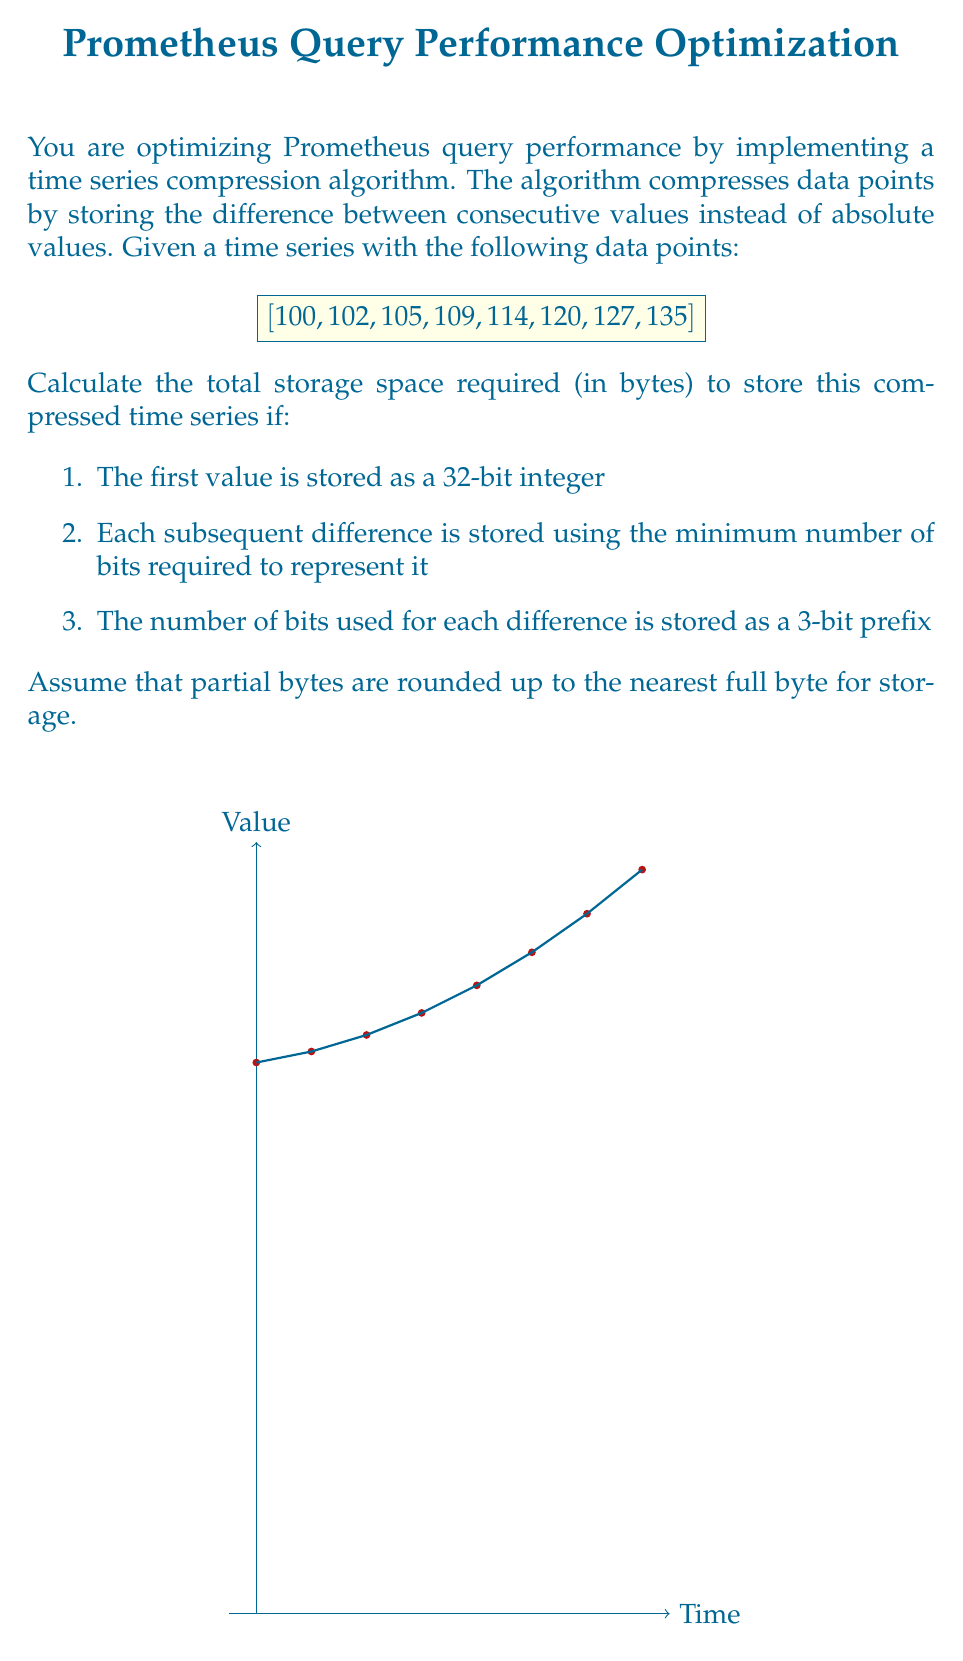Can you answer this question? Let's approach this step-by-step:

1) First, we need to calculate the differences between consecutive values:
   [100, 2, 3, 4, 5, 6, 7, 8]

2) The first value (100) is stored as a 32-bit integer, which is 4 bytes.

3) For each subsequent difference, we need to determine the minimum number of bits required:

   2: requires 2 bits ($$\log_2(2) = 1$$, rounded up to 2)
   3: requires 2 bits ($$\log_2(3) = 1.58$$, rounded up to 2)
   4: requires 3 bits ($$\log_2(4) = 2$$)
   5: requires 3 bits ($$\log_2(5) = 2.32$$, rounded up to 3)
   6: requires 3 bits ($$\log_2(6) = 2.58$$, rounded up to 3)
   7: requires 3 bits ($$\log_2(7) = 2.81$$, rounded up to 3)
   8: requires 4 bits ($$\log_2(8) = 3$$, rounded up to 4)

4) Each difference is preceded by a 3-bit prefix indicating the number of bits used.

5) Now, let's calculate the total number of bits:
   32 (first value) + 7 * 3 (prefixes) + 2 + 2 + 3 + 3 + 3 + 3 + 4 (differences) = 74 bits

6) We need to round this up to the nearest byte:
   $$\lceil 74 / 8 \rceil = 10$$ bytes

Therefore, the total storage space required is 10 bytes.
Answer: 10 bytes 